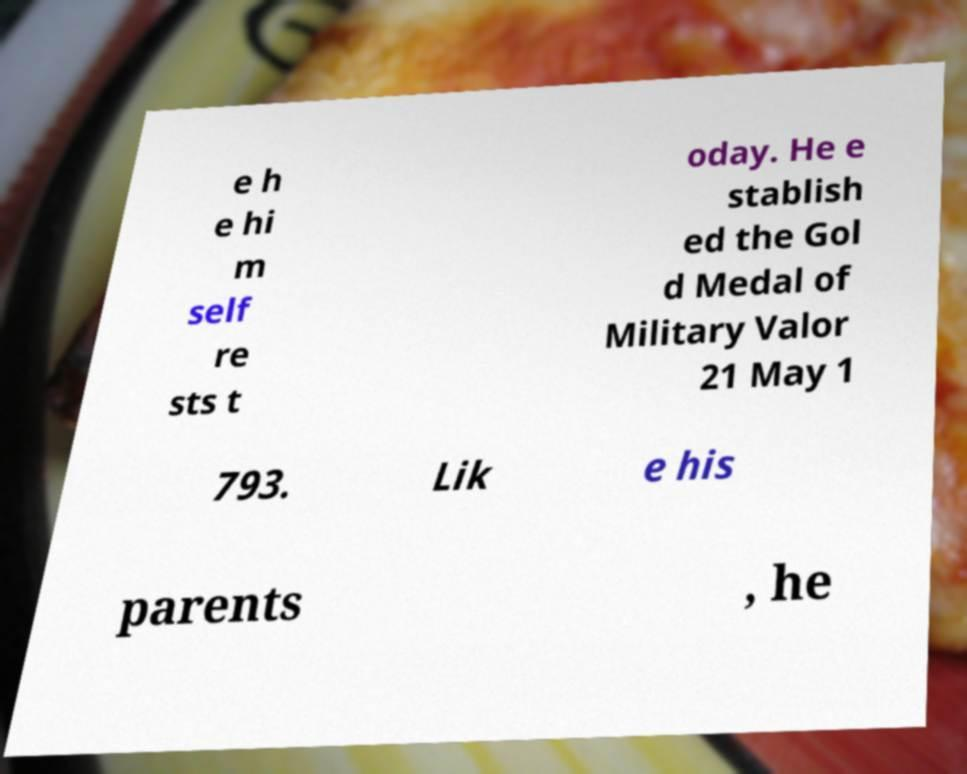There's text embedded in this image that I need extracted. Can you transcribe it verbatim? e h e hi m self re sts t oday. He e stablish ed the Gol d Medal of Military Valor 21 May 1 793. Lik e his parents , he 